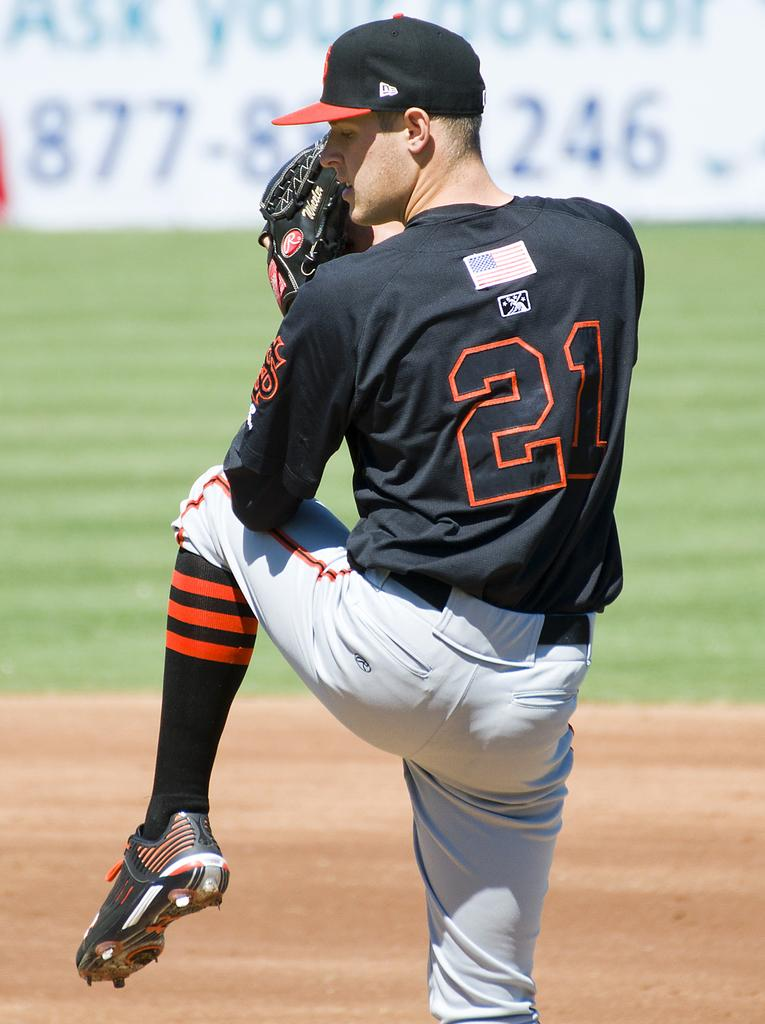<image>
Provide a brief description of the given image. Player 21 is about to pitch a ball to the other team. 